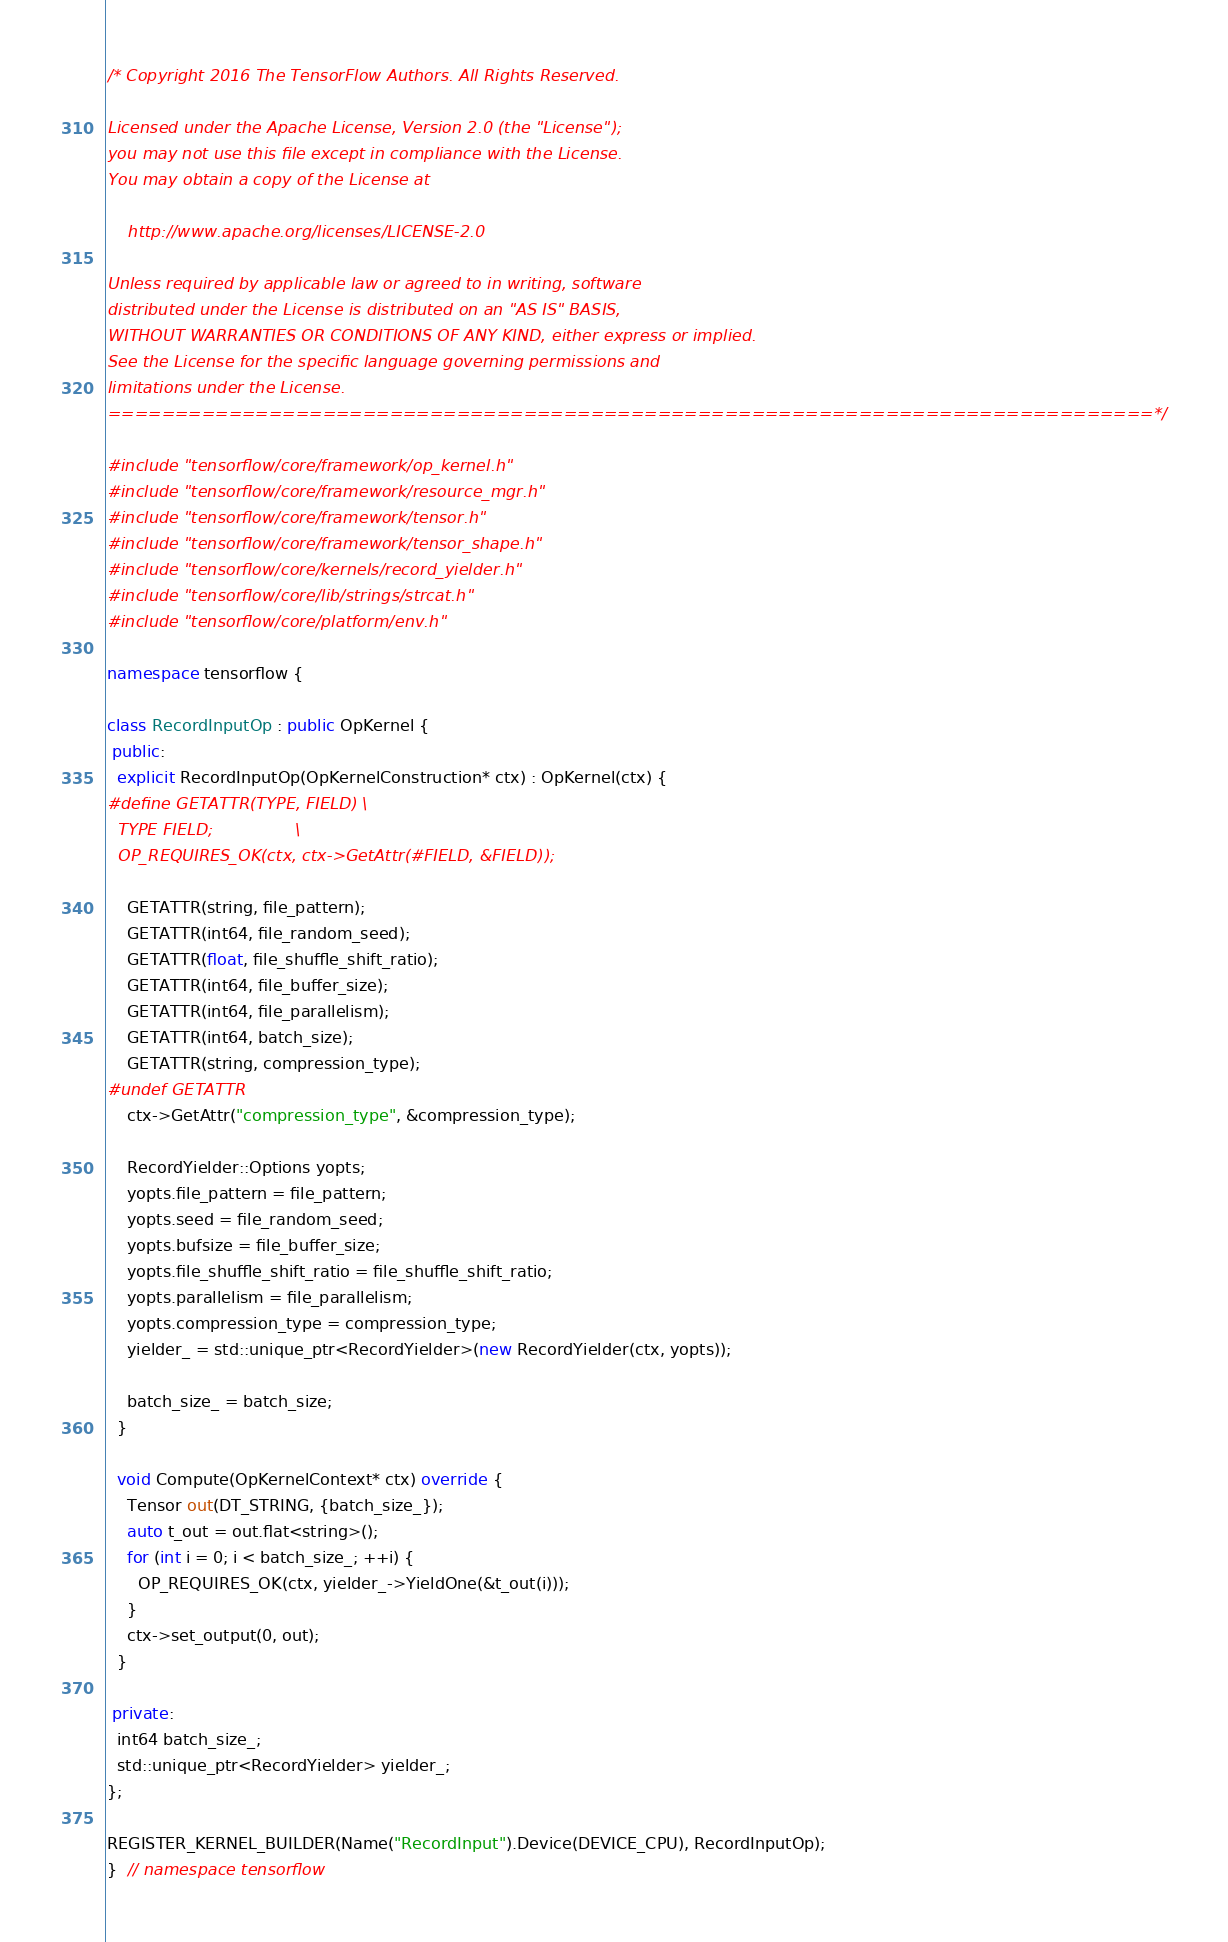<code> <loc_0><loc_0><loc_500><loc_500><_C++_>/* Copyright 2016 The TensorFlow Authors. All Rights Reserved.

Licensed under the Apache License, Version 2.0 (the "License");
you may not use this file except in compliance with the License.
You may obtain a copy of the License at

    http://www.apache.org/licenses/LICENSE-2.0

Unless required by applicable law or agreed to in writing, software
distributed under the License is distributed on an "AS IS" BASIS,
WITHOUT WARRANTIES OR CONDITIONS OF ANY KIND, either express or implied.
See the License for the specific language governing permissions and
limitations under the License.
==============================================================================*/

#include "tensorflow/core/framework/op_kernel.h"
#include "tensorflow/core/framework/resource_mgr.h"
#include "tensorflow/core/framework/tensor.h"
#include "tensorflow/core/framework/tensor_shape.h"
#include "tensorflow/core/kernels/record_yielder.h"
#include "tensorflow/core/lib/strings/strcat.h"
#include "tensorflow/core/platform/env.h"

namespace tensorflow {

class RecordInputOp : public OpKernel {
 public:
  explicit RecordInputOp(OpKernelConstruction* ctx) : OpKernel(ctx) {
#define GETATTR(TYPE, FIELD) \
  TYPE FIELD;                \
  OP_REQUIRES_OK(ctx, ctx->GetAttr(#FIELD, &FIELD));

    GETATTR(string, file_pattern);
    GETATTR(int64, file_random_seed);
    GETATTR(float, file_shuffle_shift_ratio);
    GETATTR(int64, file_buffer_size);
    GETATTR(int64, file_parallelism);
    GETATTR(int64, batch_size);
    GETATTR(string, compression_type);
#undef GETATTR
    ctx->GetAttr("compression_type", &compression_type);

    RecordYielder::Options yopts;
    yopts.file_pattern = file_pattern;
    yopts.seed = file_random_seed;
    yopts.bufsize = file_buffer_size;
    yopts.file_shuffle_shift_ratio = file_shuffle_shift_ratio;
    yopts.parallelism = file_parallelism;
    yopts.compression_type = compression_type;
    yielder_ = std::unique_ptr<RecordYielder>(new RecordYielder(ctx, yopts));

    batch_size_ = batch_size;
  }

  void Compute(OpKernelContext* ctx) override {
    Tensor out(DT_STRING, {batch_size_});
    auto t_out = out.flat<string>();
    for (int i = 0; i < batch_size_; ++i) {
      OP_REQUIRES_OK(ctx, yielder_->YieldOne(&t_out(i)));
    }
    ctx->set_output(0, out);
  }

 private:
  int64 batch_size_;
  std::unique_ptr<RecordYielder> yielder_;
};

REGISTER_KERNEL_BUILDER(Name("RecordInput").Device(DEVICE_CPU), RecordInputOp);
}  // namespace tensorflow
</code> 